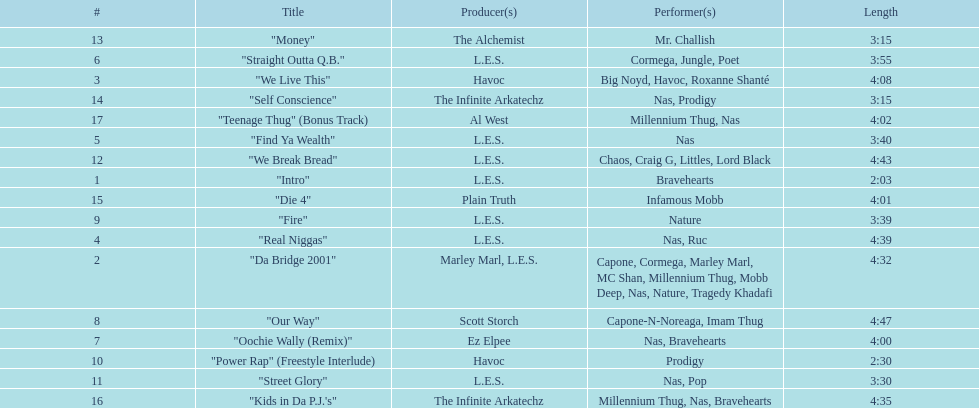Which track is longer, "money" or "die 4"? "Die 4". 